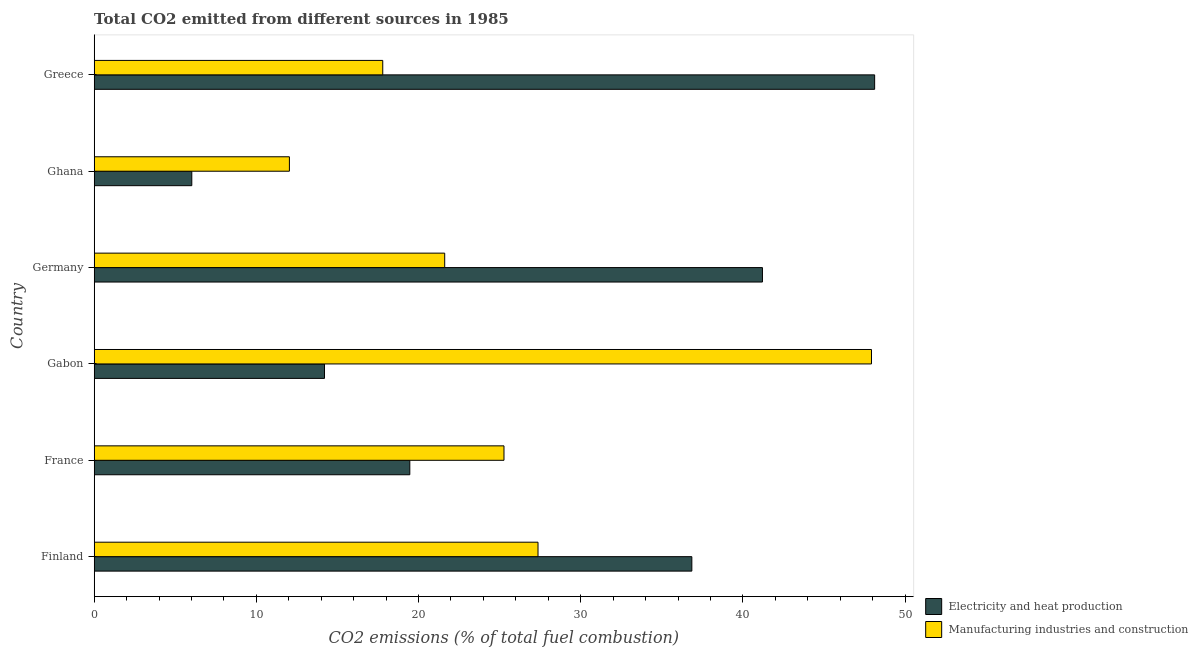Are the number of bars on each tick of the Y-axis equal?
Give a very brief answer. Yes. What is the label of the 4th group of bars from the top?
Your response must be concise. Gabon. In how many cases, is the number of bars for a given country not equal to the number of legend labels?
Provide a short and direct response. 0. What is the co2 emissions due to electricity and heat production in Greece?
Ensure brevity in your answer.  48.12. Across all countries, what is the maximum co2 emissions due to electricity and heat production?
Provide a succinct answer. 48.12. Across all countries, what is the minimum co2 emissions due to electricity and heat production?
Offer a very short reply. 6.02. In which country was the co2 emissions due to electricity and heat production minimum?
Ensure brevity in your answer.  Ghana. What is the total co2 emissions due to manufacturing industries in the graph?
Ensure brevity in your answer.  152.01. What is the difference between the co2 emissions due to manufacturing industries in Germany and that in Greece?
Provide a succinct answer. 3.82. What is the difference between the co2 emissions due to electricity and heat production in Greece and the co2 emissions due to manufacturing industries in France?
Provide a short and direct response. 22.86. What is the average co2 emissions due to electricity and heat production per country?
Keep it short and to the point. 27.64. What is the difference between the co2 emissions due to electricity and heat production and co2 emissions due to manufacturing industries in Germany?
Provide a succinct answer. 19.59. In how many countries, is the co2 emissions due to manufacturing industries greater than 8 %?
Keep it short and to the point. 6. What is the ratio of the co2 emissions due to electricity and heat production in Gabon to that in Germany?
Provide a succinct answer. 0.34. Is the co2 emissions due to electricity and heat production in Germany less than that in Ghana?
Offer a terse response. No. What is the difference between the highest and the second highest co2 emissions due to electricity and heat production?
Your answer should be very brief. 6.92. What is the difference between the highest and the lowest co2 emissions due to manufacturing industries?
Offer a terse response. 35.89. What does the 2nd bar from the top in France represents?
Ensure brevity in your answer.  Electricity and heat production. What does the 2nd bar from the bottom in Germany represents?
Offer a very short reply. Manufacturing industries and construction. How many bars are there?
Provide a succinct answer. 12. How many countries are there in the graph?
Offer a terse response. 6. What is the difference between two consecutive major ticks on the X-axis?
Keep it short and to the point. 10. Are the values on the major ticks of X-axis written in scientific E-notation?
Make the answer very short. No. Does the graph contain grids?
Make the answer very short. No. Where does the legend appear in the graph?
Keep it short and to the point. Bottom right. How many legend labels are there?
Offer a terse response. 2. What is the title of the graph?
Your answer should be compact. Total CO2 emitted from different sources in 1985. What is the label or title of the X-axis?
Your answer should be compact. CO2 emissions (% of total fuel combustion). What is the label or title of the Y-axis?
Your answer should be compact. Country. What is the CO2 emissions (% of total fuel combustion) in Electricity and heat production in Finland?
Give a very brief answer. 36.85. What is the CO2 emissions (% of total fuel combustion) of Manufacturing industries and construction in Finland?
Provide a succinct answer. 27.37. What is the CO2 emissions (% of total fuel combustion) of Electricity and heat production in France?
Your response must be concise. 19.46. What is the CO2 emissions (% of total fuel combustion) in Manufacturing industries and construction in France?
Offer a terse response. 25.27. What is the CO2 emissions (% of total fuel combustion) of Electricity and heat production in Gabon?
Ensure brevity in your answer.  14.2. What is the CO2 emissions (% of total fuel combustion) in Manufacturing industries and construction in Gabon?
Give a very brief answer. 47.93. What is the CO2 emissions (% of total fuel combustion) in Electricity and heat production in Germany?
Make the answer very short. 41.21. What is the CO2 emissions (% of total fuel combustion) in Manufacturing industries and construction in Germany?
Make the answer very short. 21.61. What is the CO2 emissions (% of total fuel combustion) of Electricity and heat production in Ghana?
Provide a short and direct response. 6.02. What is the CO2 emissions (% of total fuel combustion) of Manufacturing industries and construction in Ghana?
Your response must be concise. 12.04. What is the CO2 emissions (% of total fuel combustion) in Electricity and heat production in Greece?
Keep it short and to the point. 48.12. What is the CO2 emissions (% of total fuel combustion) of Manufacturing industries and construction in Greece?
Your response must be concise. 17.79. Across all countries, what is the maximum CO2 emissions (% of total fuel combustion) in Electricity and heat production?
Your answer should be compact. 48.12. Across all countries, what is the maximum CO2 emissions (% of total fuel combustion) of Manufacturing industries and construction?
Your response must be concise. 47.93. Across all countries, what is the minimum CO2 emissions (% of total fuel combustion) of Electricity and heat production?
Offer a terse response. 6.02. Across all countries, what is the minimum CO2 emissions (% of total fuel combustion) of Manufacturing industries and construction?
Keep it short and to the point. 12.04. What is the total CO2 emissions (% of total fuel combustion) in Electricity and heat production in the graph?
Your answer should be compact. 165.86. What is the total CO2 emissions (% of total fuel combustion) of Manufacturing industries and construction in the graph?
Your answer should be compact. 152.01. What is the difference between the CO2 emissions (% of total fuel combustion) in Electricity and heat production in Finland and that in France?
Give a very brief answer. 17.39. What is the difference between the CO2 emissions (% of total fuel combustion) in Manufacturing industries and construction in Finland and that in France?
Make the answer very short. 2.1. What is the difference between the CO2 emissions (% of total fuel combustion) in Electricity and heat production in Finland and that in Gabon?
Offer a very short reply. 22.65. What is the difference between the CO2 emissions (% of total fuel combustion) in Manufacturing industries and construction in Finland and that in Gabon?
Your answer should be compact. -20.56. What is the difference between the CO2 emissions (% of total fuel combustion) of Electricity and heat production in Finland and that in Germany?
Your answer should be compact. -4.35. What is the difference between the CO2 emissions (% of total fuel combustion) in Manufacturing industries and construction in Finland and that in Germany?
Ensure brevity in your answer.  5.75. What is the difference between the CO2 emissions (% of total fuel combustion) in Electricity and heat production in Finland and that in Ghana?
Ensure brevity in your answer.  30.83. What is the difference between the CO2 emissions (% of total fuel combustion) in Manufacturing industries and construction in Finland and that in Ghana?
Offer a terse response. 15.33. What is the difference between the CO2 emissions (% of total fuel combustion) of Electricity and heat production in Finland and that in Greece?
Keep it short and to the point. -11.27. What is the difference between the CO2 emissions (% of total fuel combustion) in Manufacturing industries and construction in Finland and that in Greece?
Your response must be concise. 9.57. What is the difference between the CO2 emissions (% of total fuel combustion) in Electricity and heat production in France and that in Gabon?
Offer a terse response. 5.26. What is the difference between the CO2 emissions (% of total fuel combustion) of Manufacturing industries and construction in France and that in Gabon?
Provide a succinct answer. -22.66. What is the difference between the CO2 emissions (% of total fuel combustion) of Electricity and heat production in France and that in Germany?
Your answer should be compact. -21.75. What is the difference between the CO2 emissions (% of total fuel combustion) of Manufacturing industries and construction in France and that in Germany?
Your answer should be very brief. 3.65. What is the difference between the CO2 emissions (% of total fuel combustion) of Electricity and heat production in France and that in Ghana?
Offer a very short reply. 13.44. What is the difference between the CO2 emissions (% of total fuel combustion) in Manufacturing industries and construction in France and that in Ghana?
Provide a short and direct response. 13.23. What is the difference between the CO2 emissions (% of total fuel combustion) of Electricity and heat production in France and that in Greece?
Offer a very short reply. -28.66. What is the difference between the CO2 emissions (% of total fuel combustion) in Manufacturing industries and construction in France and that in Greece?
Your answer should be very brief. 7.48. What is the difference between the CO2 emissions (% of total fuel combustion) in Electricity and heat production in Gabon and that in Germany?
Make the answer very short. -27. What is the difference between the CO2 emissions (% of total fuel combustion) in Manufacturing industries and construction in Gabon and that in Germany?
Provide a succinct answer. 26.32. What is the difference between the CO2 emissions (% of total fuel combustion) in Electricity and heat production in Gabon and that in Ghana?
Your answer should be compact. 8.18. What is the difference between the CO2 emissions (% of total fuel combustion) in Manufacturing industries and construction in Gabon and that in Ghana?
Ensure brevity in your answer.  35.89. What is the difference between the CO2 emissions (% of total fuel combustion) of Electricity and heat production in Gabon and that in Greece?
Keep it short and to the point. -33.92. What is the difference between the CO2 emissions (% of total fuel combustion) in Manufacturing industries and construction in Gabon and that in Greece?
Your response must be concise. 30.14. What is the difference between the CO2 emissions (% of total fuel combustion) in Electricity and heat production in Germany and that in Ghana?
Provide a short and direct response. 35.19. What is the difference between the CO2 emissions (% of total fuel combustion) of Manufacturing industries and construction in Germany and that in Ghana?
Provide a short and direct response. 9.58. What is the difference between the CO2 emissions (% of total fuel combustion) of Electricity and heat production in Germany and that in Greece?
Offer a terse response. -6.92. What is the difference between the CO2 emissions (% of total fuel combustion) in Manufacturing industries and construction in Germany and that in Greece?
Keep it short and to the point. 3.82. What is the difference between the CO2 emissions (% of total fuel combustion) of Electricity and heat production in Ghana and that in Greece?
Offer a terse response. -42.11. What is the difference between the CO2 emissions (% of total fuel combustion) in Manufacturing industries and construction in Ghana and that in Greece?
Your answer should be very brief. -5.76. What is the difference between the CO2 emissions (% of total fuel combustion) in Electricity and heat production in Finland and the CO2 emissions (% of total fuel combustion) in Manufacturing industries and construction in France?
Your response must be concise. 11.58. What is the difference between the CO2 emissions (% of total fuel combustion) in Electricity and heat production in Finland and the CO2 emissions (% of total fuel combustion) in Manufacturing industries and construction in Gabon?
Give a very brief answer. -11.08. What is the difference between the CO2 emissions (% of total fuel combustion) in Electricity and heat production in Finland and the CO2 emissions (% of total fuel combustion) in Manufacturing industries and construction in Germany?
Offer a very short reply. 15.24. What is the difference between the CO2 emissions (% of total fuel combustion) in Electricity and heat production in Finland and the CO2 emissions (% of total fuel combustion) in Manufacturing industries and construction in Ghana?
Ensure brevity in your answer.  24.81. What is the difference between the CO2 emissions (% of total fuel combustion) in Electricity and heat production in Finland and the CO2 emissions (% of total fuel combustion) in Manufacturing industries and construction in Greece?
Your response must be concise. 19.06. What is the difference between the CO2 emissions (% of total fuel combustion) in Electricity and heat production in France and the CO2 emissions (% of total fuel combustion) in Manufacturing industries and construction in Gabon?
Provide a succinct answer. -28.47. What is the difference between the CO2 emissions (% of total fuel combustion) in Electricity and heat production in France and the CO2 emissions (% of total fuel combustion) in Manufacturing industries and construction in Germany?
Keep it short and to the point. -2.15. What is the difference between the CO2 emissions (% of total fuel combustion) in Electricity and heat production in France and the CO2 emissions (% of total fuel combustion) in Manufacturing industries and construction in Ghana?
Your response must be concise. 7.42. What is the difference between the CO2 emissions (% of total fuel combustion) in Electricity and heat production in France and the CO2 emissions (% of total fuel combustion) in Manufacturing industries and construction in Greece?
Your answer should be very brief. 1.67. What is the difference between the CO2 emissions (% of total fuel combustion) of Electricity and heat production in Gabon and the CO2 emissions (% of total fuel combustion) of Manufacturing industries and construction in Germany?
Give a very brief answer. -7.41. What is the difference between the CO2 emissions (% of total fuel combustion) in Electricity and heat production in Gabon and the CO2 emissions (% of total fuel combustion) in Manufacturing industries and construction in Ghana?
Offer a very short reply. 2.16. What is the difference between the CO2 emissions (% of total fuel combustion) in Electricity and heat production in Gabon and the CO2 emissions (% of total fuel combustion) in Manufacturing industries and construction in Greece?
Provide a short and direct response. -3.59. What is the difference between the CO2 emissions (% of total fuel combustion) in Electricity and heat production in Germany and the CO2 emissions (% of total fuel combustion) in Manufacturing industries and construction in Ghana?
Provide a short and direct response. 29.17. What is the difference between the CO2 emissions (% of total fuel combustion) in Electricity and heat production in Germany and the CO2 emissions (% of total fuel combustion) in Manufacturing industries and construction in Greece?
Your answer should be very brief. 23.41. What is the difference between the CO2 emissions (% of total fuel combustion) of Electricity and heat production in Ghana and the CO2 emissions (% of total fuel combustion) of Manufacturing industries and construction in Greece?
Your response must be concise. -11.77. What is the average CO2 emissions (% of total fuel combustion) in Electricity and heat production per country?
Make the answer very short. 27.64. What is the average CO2 emissions (% of total fuel combustion) in Manufacturing industries and construction per country?
Provide a succinct answer. 25.33. What is the difference between the CO2 emissions (% of total fuel combustion) in Electricity and heat production and CO2 emissions (% of total fuel combustion) in Manufacturing industries and construction in Finland?
Ensure brevity in your answer.  9.49. What is the difference between the CO2 emissions (% of total fuel combustion) of Electricity and heat production and CO2 emissions (% of total fuel combustion) of Manufacturing industries and construction in France?
Provide a short and direct response. -5.81. What is the difference between the CO2 emissions (% of total fuel combustion) of Electricity and heat production and CO2 emissions (% of total fuel combustion) of Manufacturing industries and construction in Gabon?
Provide a short and direct response. -33.73. What is the difference between the CO2 emissions (% of total fuel combustion) of Electricity and heat production and CO2 emissions (% of total fuel combustion) of Manufacturing industries and construction in Germany?
Make the answer very short. 19.59. What is the difference between the CO2 emissions (% of total fuel combustion) in Electricity and heat production and CO2 emissions (% of total fuel combustion) in Manufacturing industries and construction in Ghana?
Your answer should be very brief. -6.02. What is the difference between the CO2 emissions (% of total fuel combustion) of Electricity and heat production and CO2 emissions (% of total fuel combustion) of Manufacturing industries and construction in Greece?
Provide a short and direct response. 30.33. What is the ratio of the CO2 emissions (% of total fuel combustion) in Electricity and heat production in Finland to that in France?
Provide a succinct answer. 1.89. What is the ratio of the CO2 emissions (% of total fuel combustion) of Manufacturing industries and construction in Finland to that in France?
Your response must be concise. 1.08. What is the ratio of the CO2 emissions (% of total fuel combustion) in Electricity and heat production in Finland to that in Gabon?
Provide a short and direct response. 2.6. What is the ratio of the CO2 emissions (% of total fuel combustion) of Manufacturing industries and construction in Finland to that in Gabon?
Your response must be concise. 0.57. What is the ratio of the CO2 emissions (% of total fuel combustion) of Electricity and heat production in Finland to that in Germany?
Offer a terse response. 0.89. What is the ratio of the CO2 emissions (% of total fuel combustion) in Manufacturing industries and construction in Finland to that in Germany?
Provide a succinct answer. 1.27. What is the ratio of the CO2 emissions (% of total fuel combustion) of Electricity and heat production in Finland to that in Ghana?
Keep it short and to the point. 6.12. What is the ratio of the CO2 emissions (% of total fuel combustion) of Manufacturing industries and construction in Finland to that in Ghana?
Offer a very short reply. 2.27. What is the ratio of the CO2 emissions (% of total fuel combustion) of Electricity and heat production in Finland to that in Greece?
Your answer should be very brief. 0.77. What is the ratio of the CO2 emissions (% of total fuel combustion) in Manufacturing industries and construction in Finland to that in Greece?
Provide a short and direct response. 1.54. What is the ratio of the CO2 emissions (% of total fuel combustion) of Electricity and heat production in France to that in Gabon?
Provide a succinct answer. 1.37. What is the ratio of the CO2 emissions (% of total fuel combustion) in Manufacturing industries and construction in France to that in Gabon?
Offer a very short reply. 0.53. What is the ratio of the CO2 emissions (% of total fuel combustion) of Electricity and heat production in France to that in Germany?
Your answer should be very brief. 0.47. What is the ratio of the CO2 emissions (% of total fuel combustion) of Manufacturing industries and construction in France to that in Germany?
Your answer should be very brief. 1.17. What is the ratio of the CO2 emissions (% of total fuel combustion) in Electricity and heat production in France to that in Ghana?
Provide a short and direct response. 3.23. What is the ratio of the CO2 emissions (% of total fuel combustion) in Manufacturing industries and construction in France to that in Ghana?
Provide a short and direct response. 2.1. What is the ratio of the CO2 emissions (% of total fuel combustion) of Electricity and heat production in France to that in Greece?
Ensure brevity in your answer.  0.4. What is the ratio of the CO2 emissions (% of total fuel combustion) of Manufacturing industries and construction in France to that in Greece?
Give a very brief answer. 1.42. What is the ratio of the CO2 emissions (% of total fuel combustion) of Electricity and heat production in Gabon to that in Germany?
Make the answer very short. 0.34. What is the ratio of the CO2 emissions (% of total fuel combustion) in Manufacturing industries and construction in Gabon to that in Germany?
Offer a terse response. 2.22. What is the ratio of the CO2 emissions (% of total fuel combustion) of Electricity and heat production in Gabon to that in Ghana?
Give a very brief answer. 2.36. What is the ratio of the CO2 emissions (% of total fuel combustion) in Manufacturing industries and construction in Gabon to that in Ghana?
Offer a terse response. 3.98. What is the ratio of the CO2 emissions (% of total fuel combustion) of Electricity and heat production in Gabon to that in Greece?
Provide a succinct answer. 0.3. What is the ratio of the CO2 emissions (% of total fuel combustion) of Manufacturing industries and construction in Gabon to that in Greece?
Provide a succinct answer. 2.69. What is the ratio of the CO2 emissions (% of total fuel combustion) of Electricity and heat production in Germany to that in Ghana?
Your response must be concise. 6.85. What is the ratio of the CO2 emissions (% of total fuel combustion) in Manufacturing industries and construction in Germany to that in Ghana?
Your response must be concise. 1.8. What is the ratio of the CO2 emissions (% of total fuel combustion) of Electricity and heat production in Germany to that in Greece?
Your answer should be very brief. 0.86. What is the ratio of the CO2 emissions (% of total fuel combustion) of Manufacturing industries and construction in Germany to that in Greece?
Give a very brief answer. 1.21. What is the ratio of the CO2 emissions (% of total fuel combustion) in Electricity and heat production in Ghana to that in Greece?
Offer a very short reply. 0.13. What is the ratio of the CO2 emissions (% of total fuel combustion) in Manufacturing industries and construction in Ghana to that in Greece?
Your answer should be compact. 0.68. What is the difference between the highest and the second highest CO2 emissions (% of total fuel combustion) of Electricity and heat production?
Provide a succinct answer. 6.92. What is the difference between the highest and the second highest CO2 emissions (% of total fuel combustion) of Manufacturing industries and construction?
Make the answer very short. 20.56. What is the difference between the highest and the lowest CO2 emissions (% of total fuel combustion) in Electricity and heat production?
Provide a short and direct response. 42.11. What is the difference between the highest and the lowest CO2 emissions (% of total fuel combustion) in Manufacturing industries and construction?
Give a very brief answer. 35.89. 